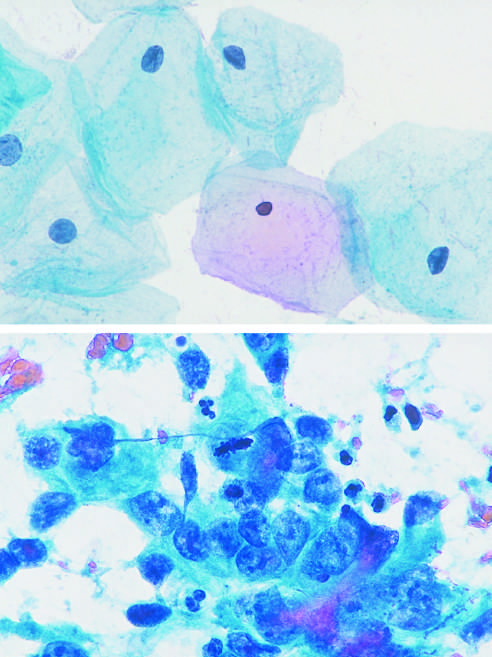what is in mitosis?
Answer the question using a single word or phrase. One cell 